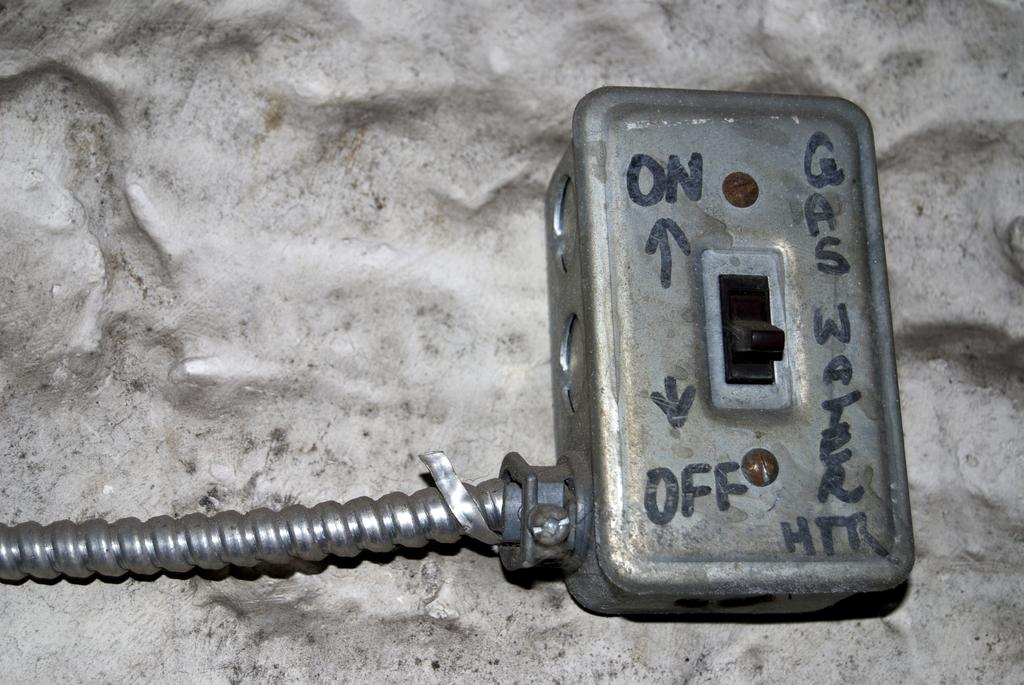<image>
Give a short and clear explanation of the subsequent image. A grey on off switch that powers a gas water heater. 